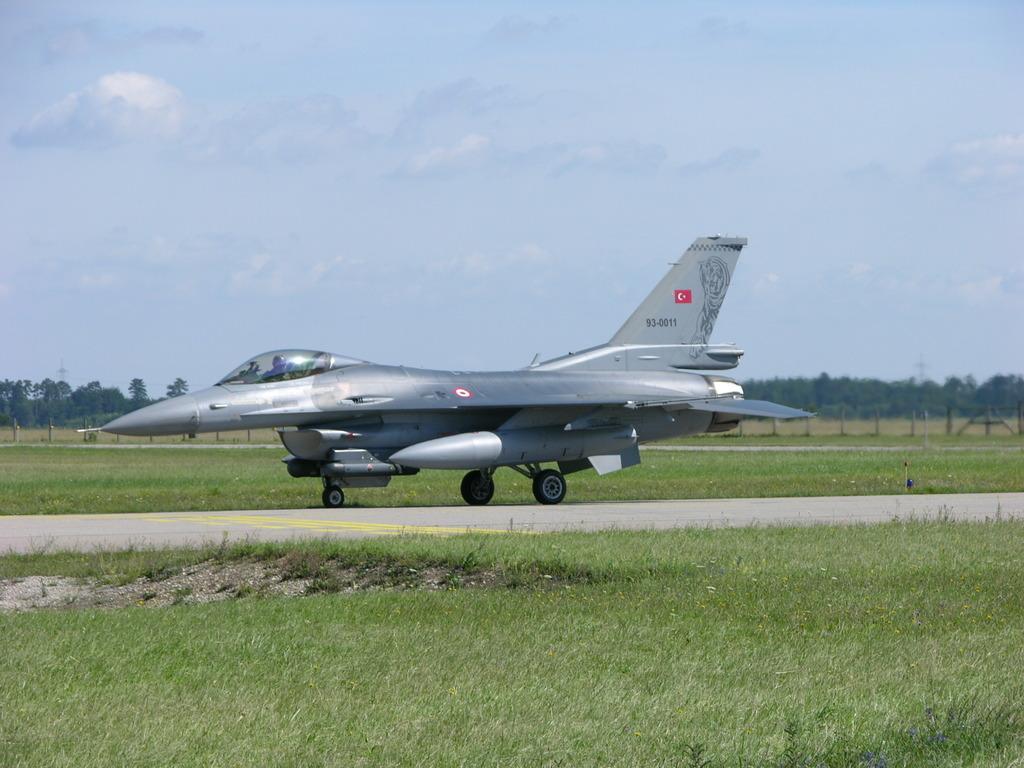Can you describe this image briefly? In this image in the center there is an airplane, and at the bottom there is grass and walkway. And in the background there are some poles and trees, at the top there is sky. 